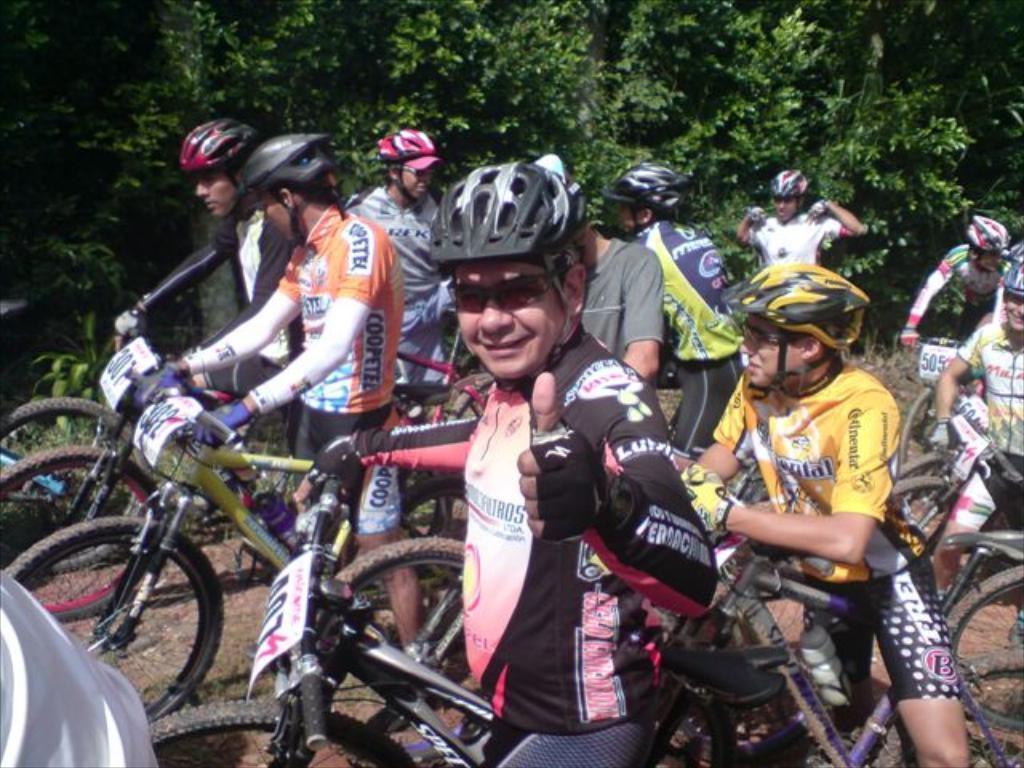Describe this image in one or two sentences. In this image I can see number of people are with their cycles. I can see everyone is wearing helmets. 